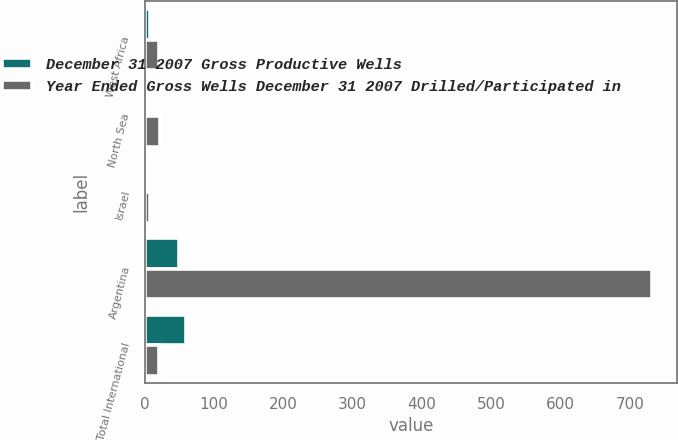Convert chart. <chart><loc_0><loc_0><loc_500><loc_500><stacked_bar_chart><ecel><fcel>West Africa<fcel>North Sea<fcel>Israel<fcel>Argentina<fcel>Total International<nl><fcel>December 31 2007 Gross Productive Wells<fcel>7<fcel>2<fcel>1<fcel>50<fcel>60<nl><fcel>Year Ended Gross Wells December 31 2007 Drilled/Participated in<fcel>20<fcel>22<fcel>8<fcel>732<fcel>20<nl></chart> 